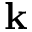Convert formula to latex. <formula><loc_0><loc_0><loc_500><loc_500>k</formula> 